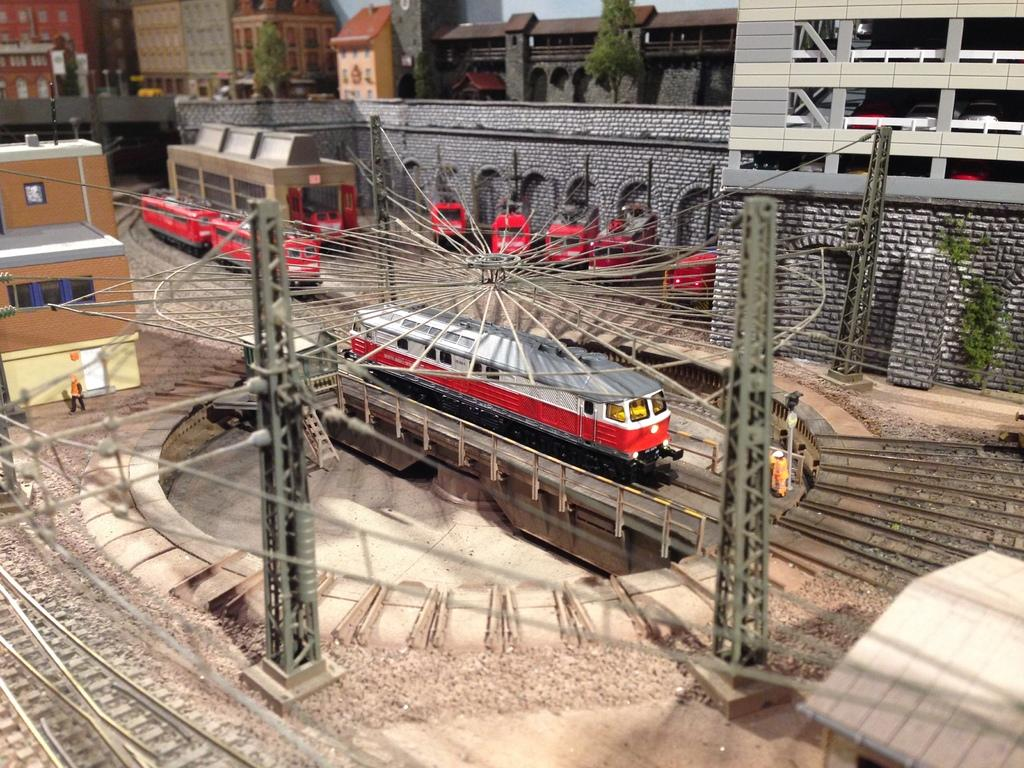What type of vehicles can be seen in the image? There are trains on tracks in the image. What type of structures are present in the image? There are buildings, a house, and towers in the image. What type of vegetation is present in the image? Trees are present in the image. What type of barrier is visible in the image? A wall is visible in the image. What part of the natural environment is visible in the image? The sky is visible in the image. Can you tell me how many cubs are playing basketball in the image? There are no cubs or basketballs present in the image. What color is the rub on the wall in the image? There is no mention of a rub on the wall in the image; only a wall is visible. 